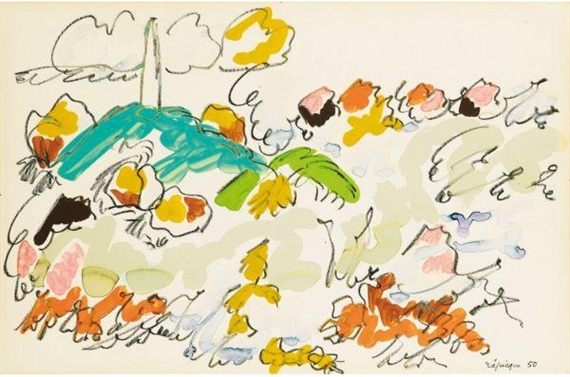If this artwork could talk, what story do you think it would tell? I am a canvas of dreams, brought to life by strokes of imagination. My tale begins with a single brush of blue, depicting the essence of flight and freedom in the form of a bird named Azure. Next came Verdant, a grand palm tree, its fronds swaying gently in the breeze of creativity. Together, we welcomed a medley of flowers, each one a burst of color and life, representing the myriad facets of human emotion. Above us floated clouds of gray, a reminder that even in the most vibrant moments, there lies a touch of contemplation. I am a celebration of the abstract, where every viewer sees a piece of their soul reflected in my hues and lines. My story is one of openness, inviting all to find their own meaning within my swirls and splashes. Can you describe a scene where a character interacts with this world? In a world where the imagination takes form in colors and shapes, a curious artist named Liesl stepped into the canvas. The moment her feet touched the ground, she felt the vibrant energy of the garden envelop her. Around her, flowers in a riot of colors blossomed and danced. Azure, the blue bird, swooped down to greet her, leading her to Verdant, the wise palm tree. Verdant spoke in rustles and whispers, revealing secrets of the art world that Liesl had never dreamed of. As she wandered deeper, the ground beneath her feet morphed, responding to her thoughts and feelings. She painted new paths with her steps, flowers blooming in her wake. Liesl realized she had the power to bring her artistic visions to life in this magical place, learning that her creativity knew no boundaries in this abstract paradise. 